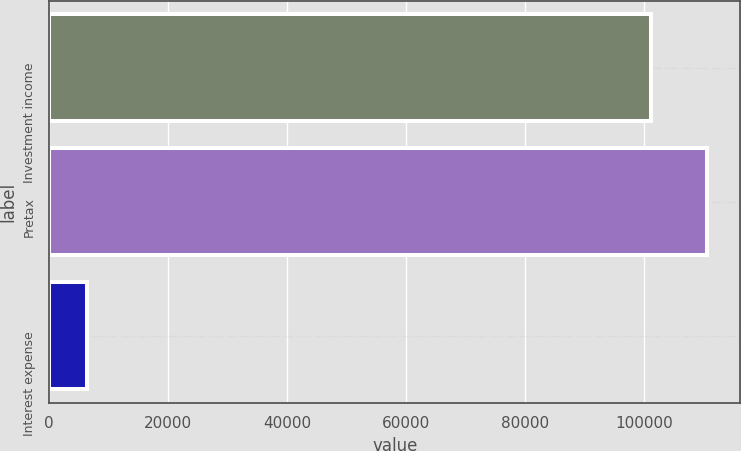Convert chart to OTSL. <chart><loc_0><loc_0><loc_500><loc_500><bar_chart><fcel>Investment income<fcel>Pretax<fcel>Interest expense<nl><fcel>101142<fcel>110618<fcel>6384<nl></chart> 